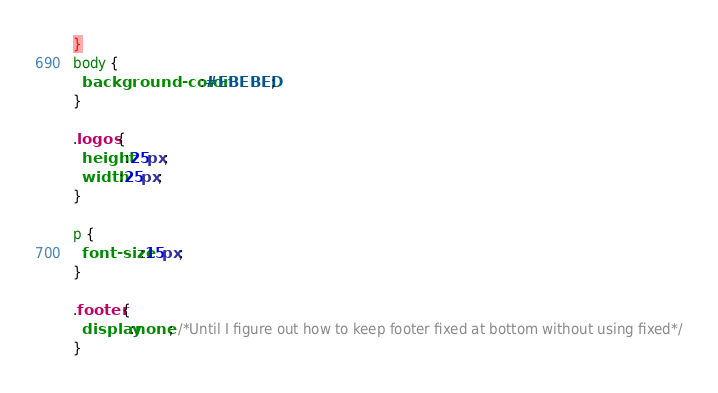Convert code to text. <code><loc_0><loc_0><loc_500><loc_500><_CSS_>}
body {
  background-color:#EBEBED;
}

.logos {
  height:25px;
  width:25px;
}

p {
  font-size:15px;
}

.footer {
  display:none; /*Until I figure out how to keep footer fixed at bottom without using fixed*/
}
</code> 